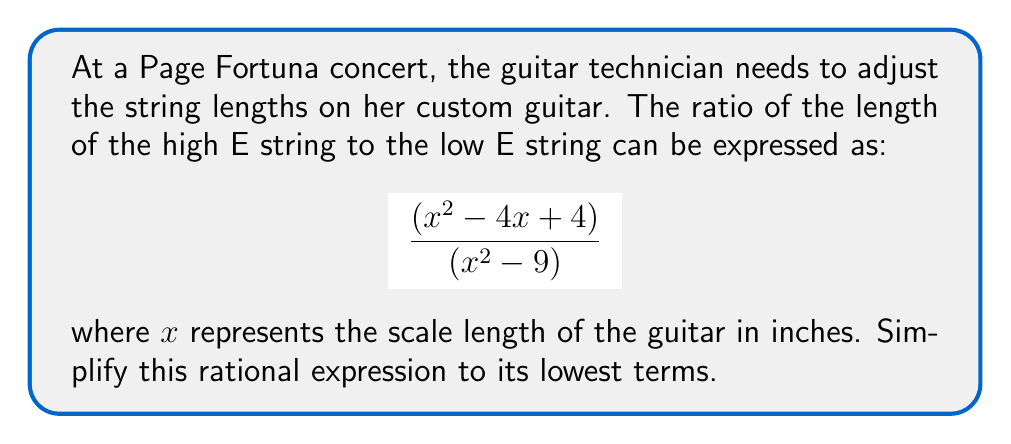What is the answer to this math problem? Let's simplify this rational expression step by step:

1) First, let's factor the numerator and denominator:

   Numerator: $x^2 - 4x + 4 = (x - 2)(x - 2)$
   Denominator: $x^2 - 9 = (x + 3)(x - 3)$

2) Now our expression looks like this:

   $$ \frac{(x - 2)(x - 2)}{(x + 3)(x - 3)} $$

3) We can see that $(x - 2)$ appears twice in the numerator. We can simplify this to:

   $$ \frac{(x - 2)^2}{(x + 3)(x - 3)} $$

4) At this point, we can't factor out any common terms between the numerator and denominator.

5) However, we need to consider the domain of this expression. The denominator can't be zero, so:

   $x + 3 \neq 0$ and $x - 3 \neq 0$
   $x \neq -3$ and $x \neq 3$

6) Therefore, the final simplified expression, with its domain restriction, is:

   $$ \frac{(x - 2)^2}{(x + 3)(x - 3)}, \text{ where } x \neq 3 \text{ and } x \neq -3 $$

This is the most simplified form of the rational expression.
Answer: $\frac{(x - 2)^2}{(x + 3)(x - 3)}, x \neq 3, x \neq -3$ 